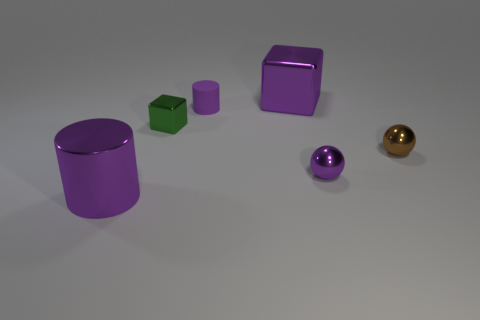How many other large cylinders are the same color as the large cylinder? 0 